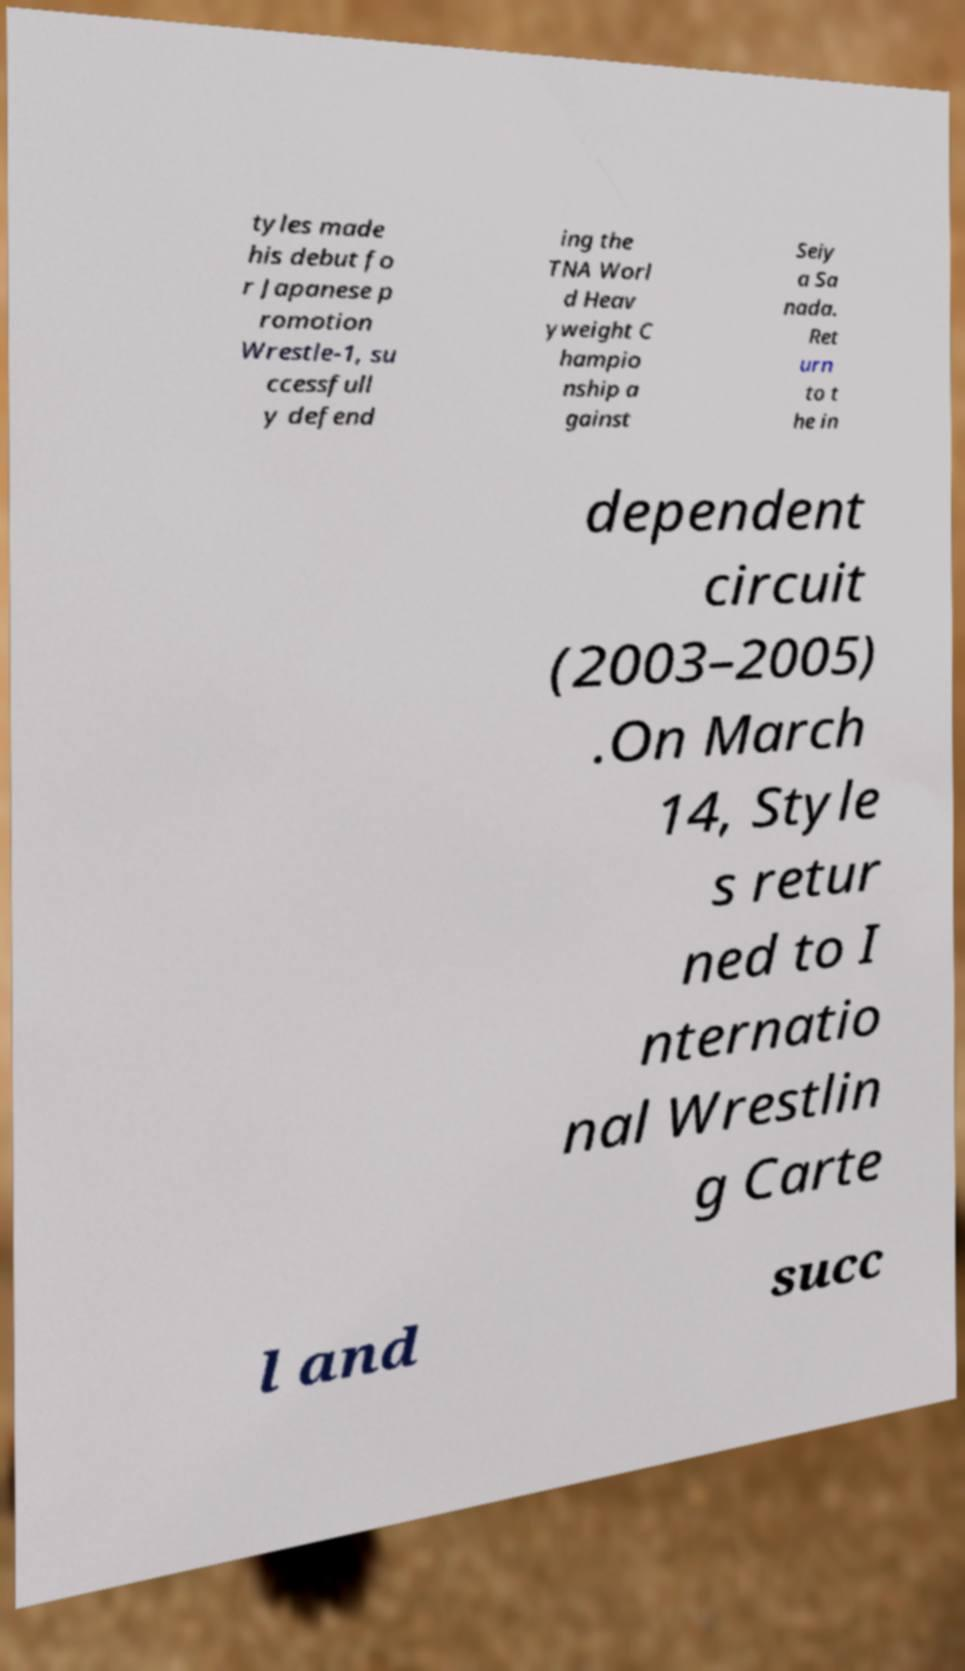Please read and relay the text visible in this image. What does it say? tyles made his debut fo r Japanese p romotion Wrestle-1, su ccessfull y defend ing the TNA Worl d Heav yweight C hampio nship a gainst Seiy a Sa nada. Ret urn to t he in dependent circuit (2003–2005) .On March 14, Style s retur ned to I nternatio nal Wrestlin g Carte l and succ 